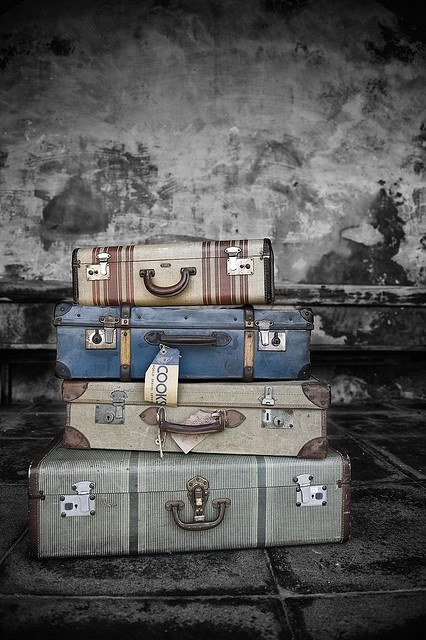Describe the objects in this image and their specific colors. I can see suitcase in black, darkgray, gray, and lightgray tones, suitcase in black, darkgray, and gray tones, suitcase in black, gray, and blue tones, and suitcase in black, darkgray, lightgray, and gray tones in this image. 